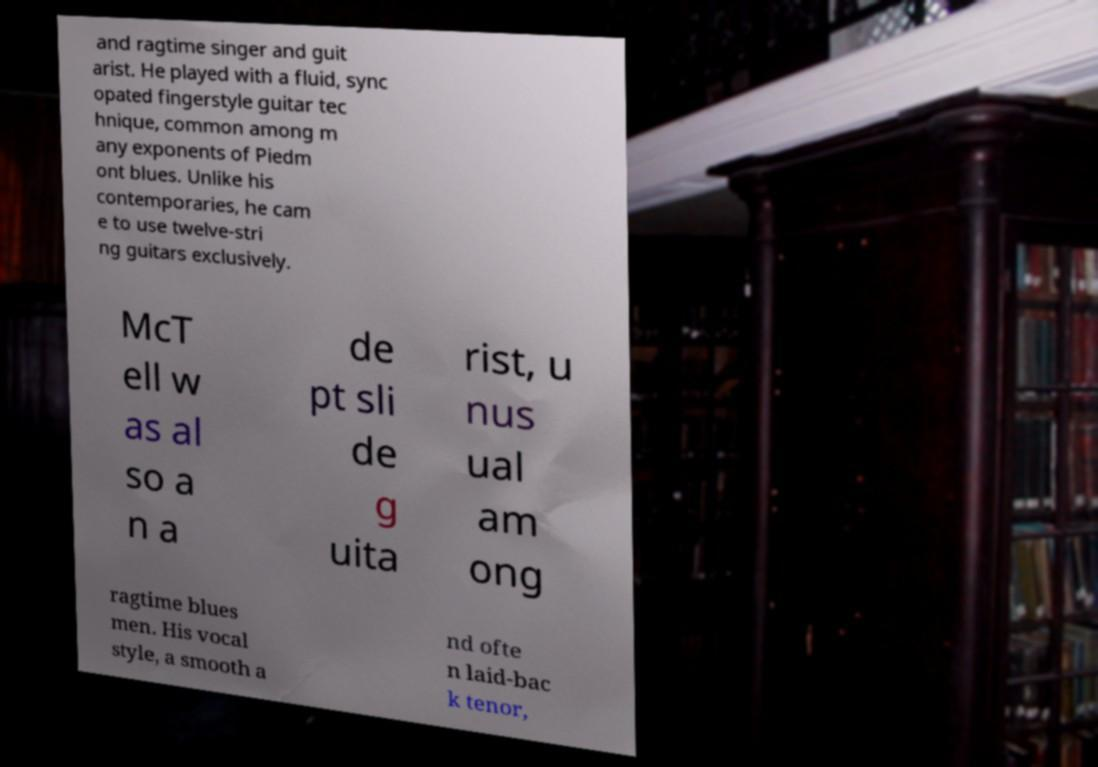Please identify and transcribe the text found in this image. and ragtime singer and guit arist. He played with a fluid, sync opated fingerstyle guitar tec hnique, common among m any exponents of Piedm ont blues. Unlike his contemporaries, he cam e to use twelve-stri ng guitars exclusively. McT ell w as al so a n a de pt sli de g uita rist, u nus ual am ong ragtime blues men. His vocal style, a smooth a nd ofte n laid-bac k tenor, 